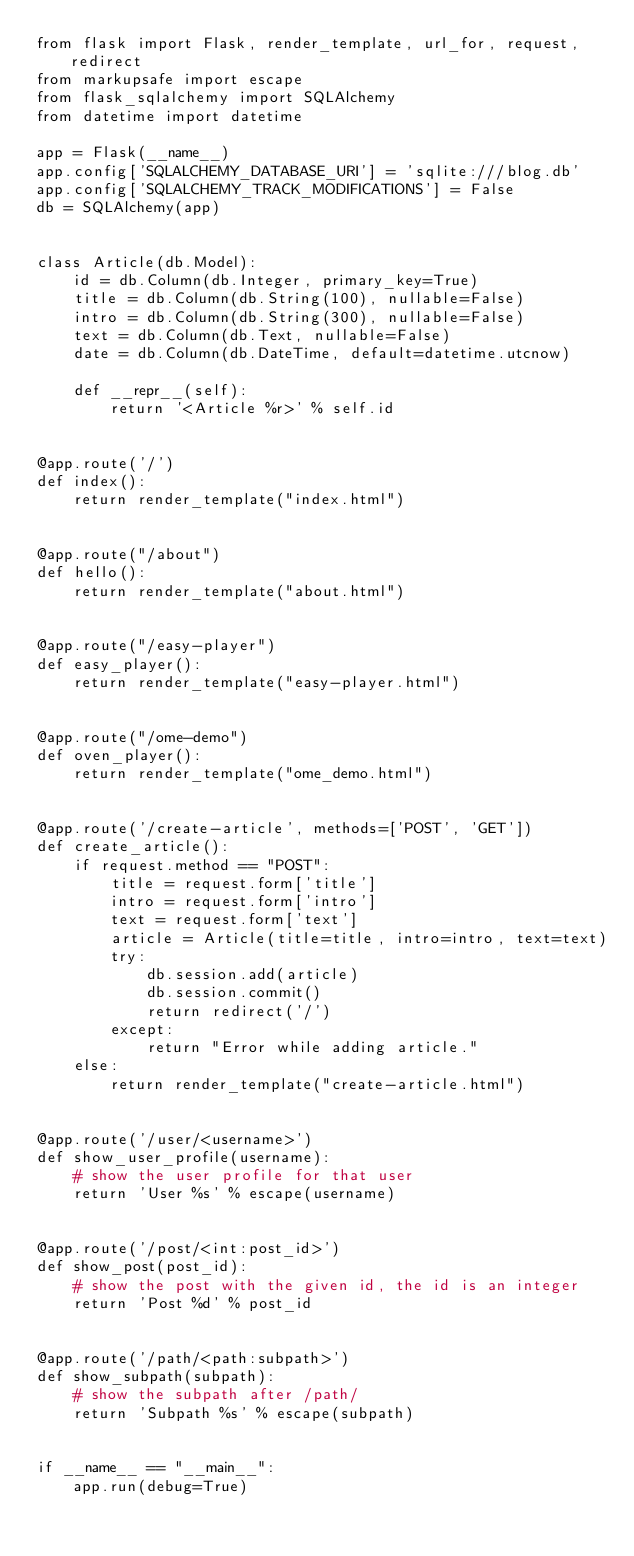Convert code to text. <code><loc_0><loc_0><loc_500><loc_500><_Python_>from flask import Flask, render_template, url_for, request, redirect
from markupsafe import escape
from flask_sqlalchemy import SQLAlchemy
from datetime import datetime

app = Flask(__name__)
app.config['SQLALCHEMY_DATABASE_URI'] = 'sqlite:///blog.db'
app.config['SQLALCHEMY_TRACK_MODIFICATIONS'] = False
db = SQLAlchemy(app)


class Article(db.Model):
    id = db.Column(db.Integer, primary_key=True)
    title = db.Column(db.String(100), nullable=False)
    intro = db.Column(db.String(300), nullable=False)
    text = db.Column(db.Text, nullable=False)
    date = db.Column(db.DateTime, default=datetime.utcnow)

    def __repr__(self):
        return '<Article %r>' % self.id


@app.route('/')
def index():
    return render_template("index.html")


@app.route("/about")
def hello():
    return render_template("about.html")


@app.route("/easy-player")
def easy_player():
    return render_template("easy-player.html")


@app.route("/ome-demo")
def oven_player():
    return render_template("ome_demo.html")


@app.route('/create-article', methods=['POST', 'GET'])
def create_article():
    if request.method == "POST":
        title = request.form['title']
        intro = request.form['intro']
        text = request.form['text']
        article = Article(title=title, intro=intro, text=text)
        try:
            db.session.add(article)
            db.session.commit()
            return redirect('/')
        except:
            return "Error while adding article."
    else:
        return render_template("create-article.html")


@app.route('/user/<username>')
def show_user_profile(username):
    # show the user profile for that user
    return 'User %s' % escape(username)


@app.route('/post/<int:post_id>')
def show_post(post_id):
    # show the post with the given id, the id is an integer
    return 'Post %d' % post_id


@app.route('/path/<path:subpath>')
def show_subpath(subpath):
    # show the subpath after /path/
    return 'Subpath %s' % escape(subpath)


if __name__ == "__main__":
    app.run(debug=True)
</code> 